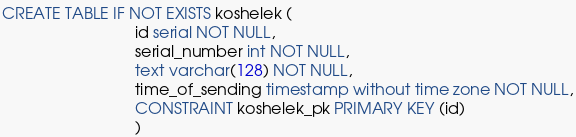<code> <loc_0><loc_0><loc_500><loc_500><_SQL_>CREATE TABLE IF NOT EXISTS koshelek (
                              id serial NOT NULL,
                              serial_number int NOT NULL,
                              text varchar(128) NOT NULL,
                              time_of_sending timestamp without time zone NOT NULL,
                              CONSTRAINT koshelek_pk PRIMARY KEY (id)
                              )</code> 